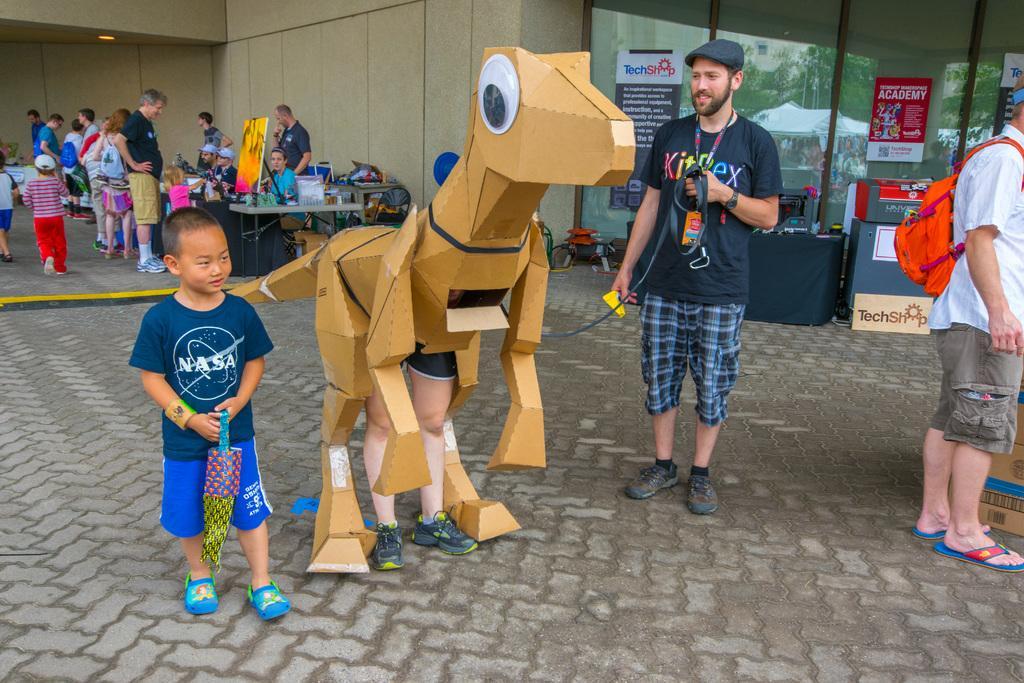In one or two sentences, can you explain what this image depicts? In this image we can see some people and among them few people are standing and few people are sitting and there is a person wearing a costume like an animal. We can see the tables in the background with some objects and there are some boards with text and we can see some things on the floor. 